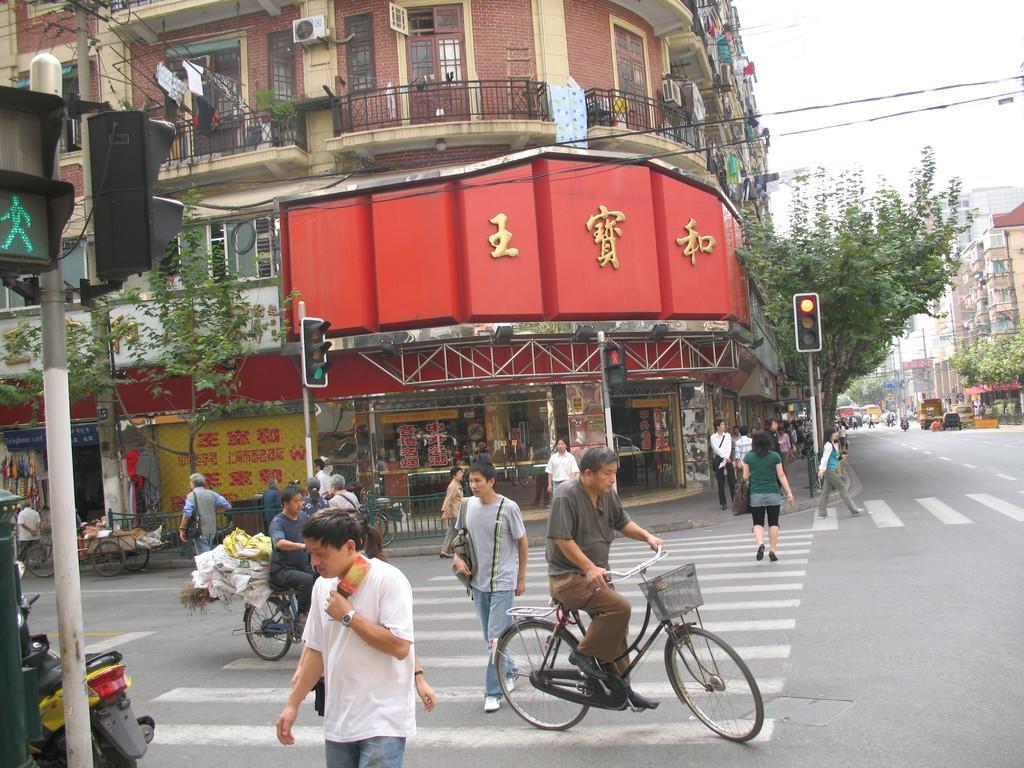How would you summarize this image in a sentence or two? This picture shows a building, few people walking on the road and a person riding a bicycle. we see couple of trees. 